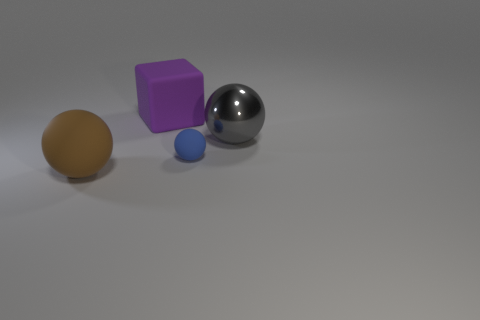There is a gray metal sphere; what number of large spheres are on the left side of it?
Your answer should be compact. 1. Is the color of the rubber sphere that is right of the big brown thing the same as the cube?
Provide a succinct answer. No. How many blue matte objects are the same size as the gray thing?
Keep it short and to the point. 0. The purple object that is made of the same material as the big brown sphere is what shape?
Your answer should be very brief. Cube. Are there any large matte objects of the same color as the cube?
Ensure brevity in your answer.  No. What is the material of the blue object?
Your response must be concise. Rubber. What number of objects are blue balls or large rubber things?
Your response must be concise. 3. How big is the rubber sphere that is behind the large rubber ball?
Offer a terse response. Small. What number of other objects are the same material as the small blue thing?
Ensure brevity in your answer.  2. There is a big object in front of the gray metal ball; are there any big things that are to the right of it?
Give a very brief answer. Yes. 